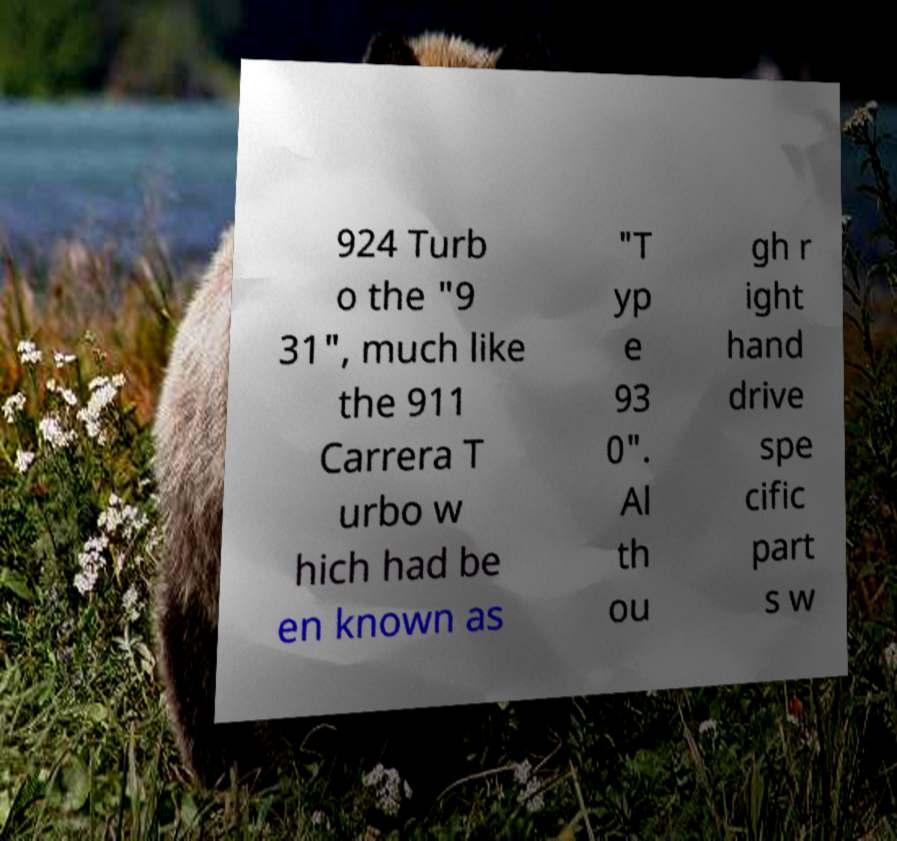Please read and relay the text visible in this image. What does it say? 924 Turb o the "9 31", much like the 911 Carrera T urbo w hich had be en known as "T yp e 93 0". Al th ou gh r ight hand drive spe cific part s w 